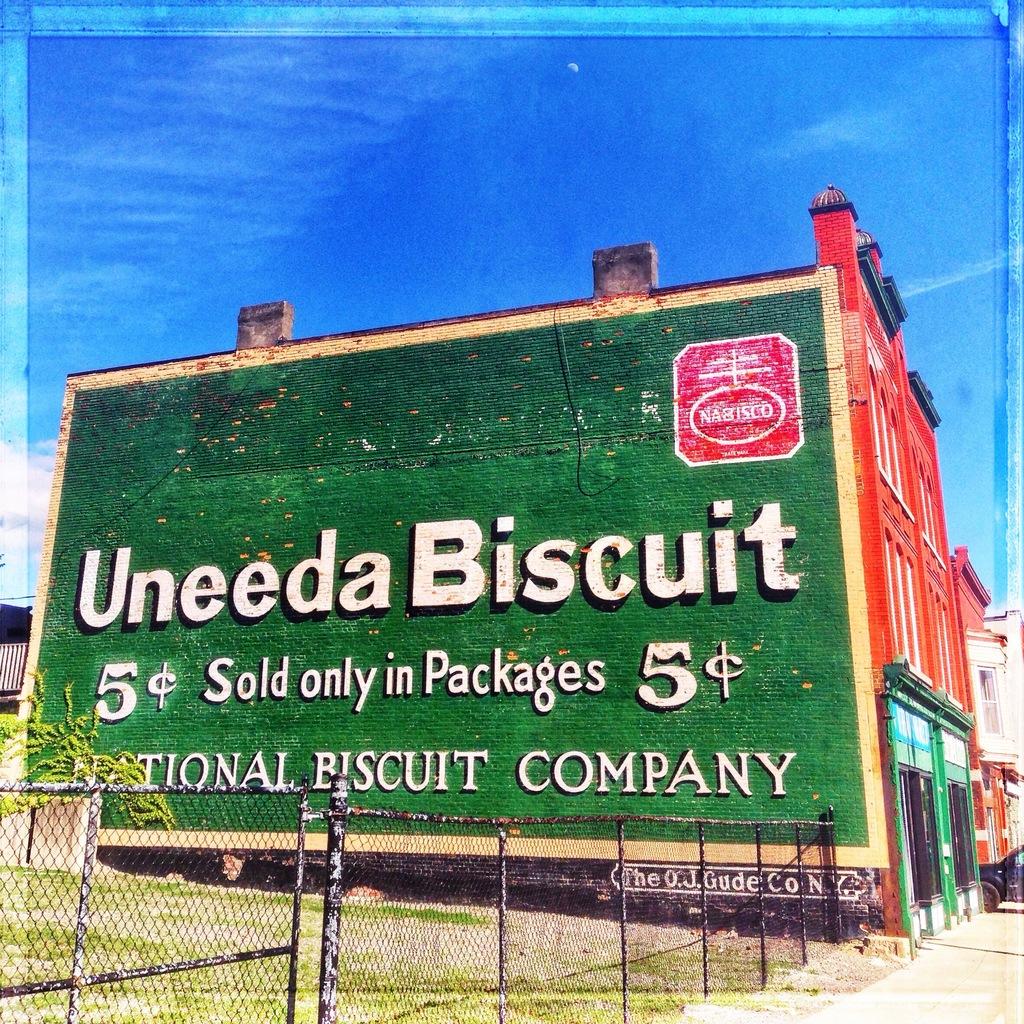What is the company name?
Offer a very short reply. Nabisco. How much does it cost for a biscuit?
Offer a very short reply. 5 cents. 